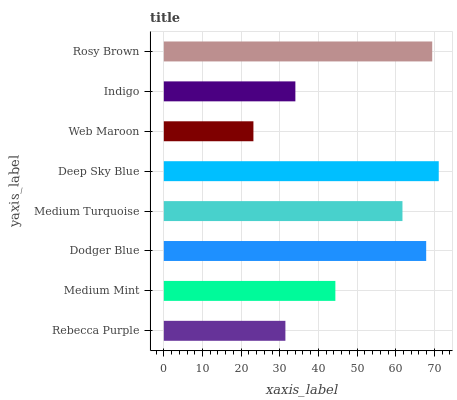Is Web Maroon the minimum?
Answer yes or no. Yes. Is Deep Sky Blue the maximum?
Answer yes or no. Yes. Is Medium Mint the minimum?
Answer yes or no. No. Is Medium Mint the maximum?
Answer yes or no. No. Is Medium Mint greater than Rebecca Purple?
Answer yes or no. Yes. Is Rebecca Purple less than Medium Mint?
Answer yes or no. Yes. Is Rebecca Purple greater than Medium Mint?
Answer yes or no. No. Is Medium Mint less than Rebecca Purple?
Answer yes or no. No. Is Medium Turquoise the high median?
Answer yes or no. Yes. Is Medium Mint the low median?
Answer yes or no. Yes. Is Rebecca Purple the high median?
Answer yes or no. No. Is Rosy Brown the low median?
Answer yes or no. No. 